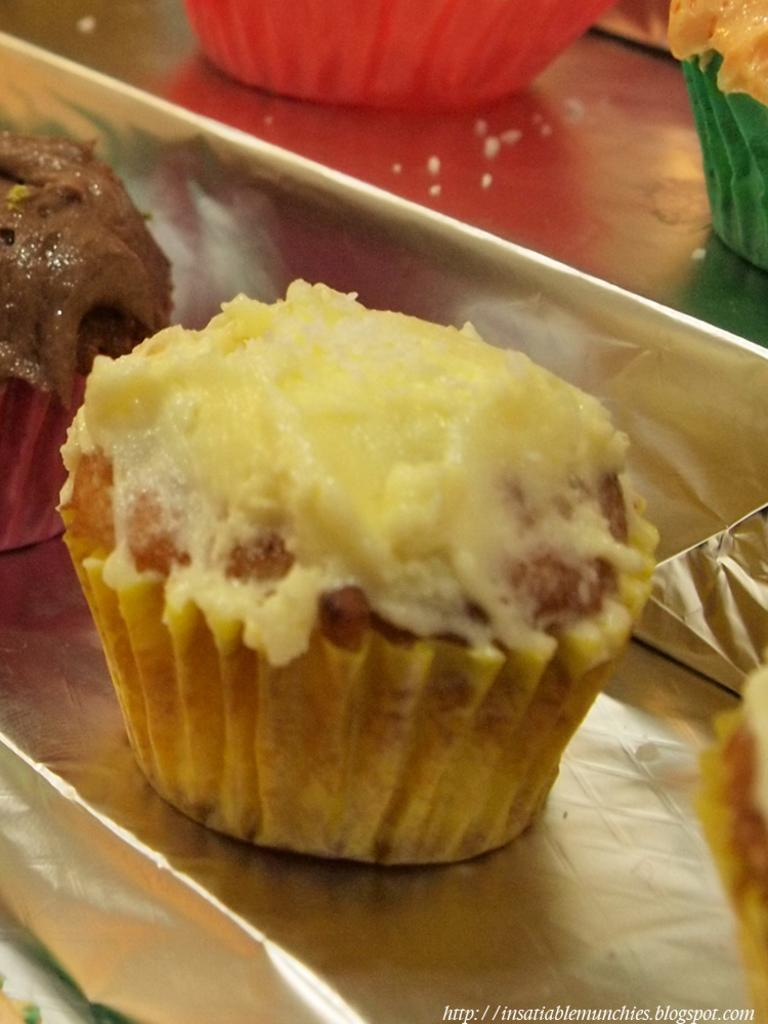What type of food can be seen in the image? There are muffins in the image. What type of cart is used to transport the muffins in the image? There is no cart present in the image; it only shows muffins. 